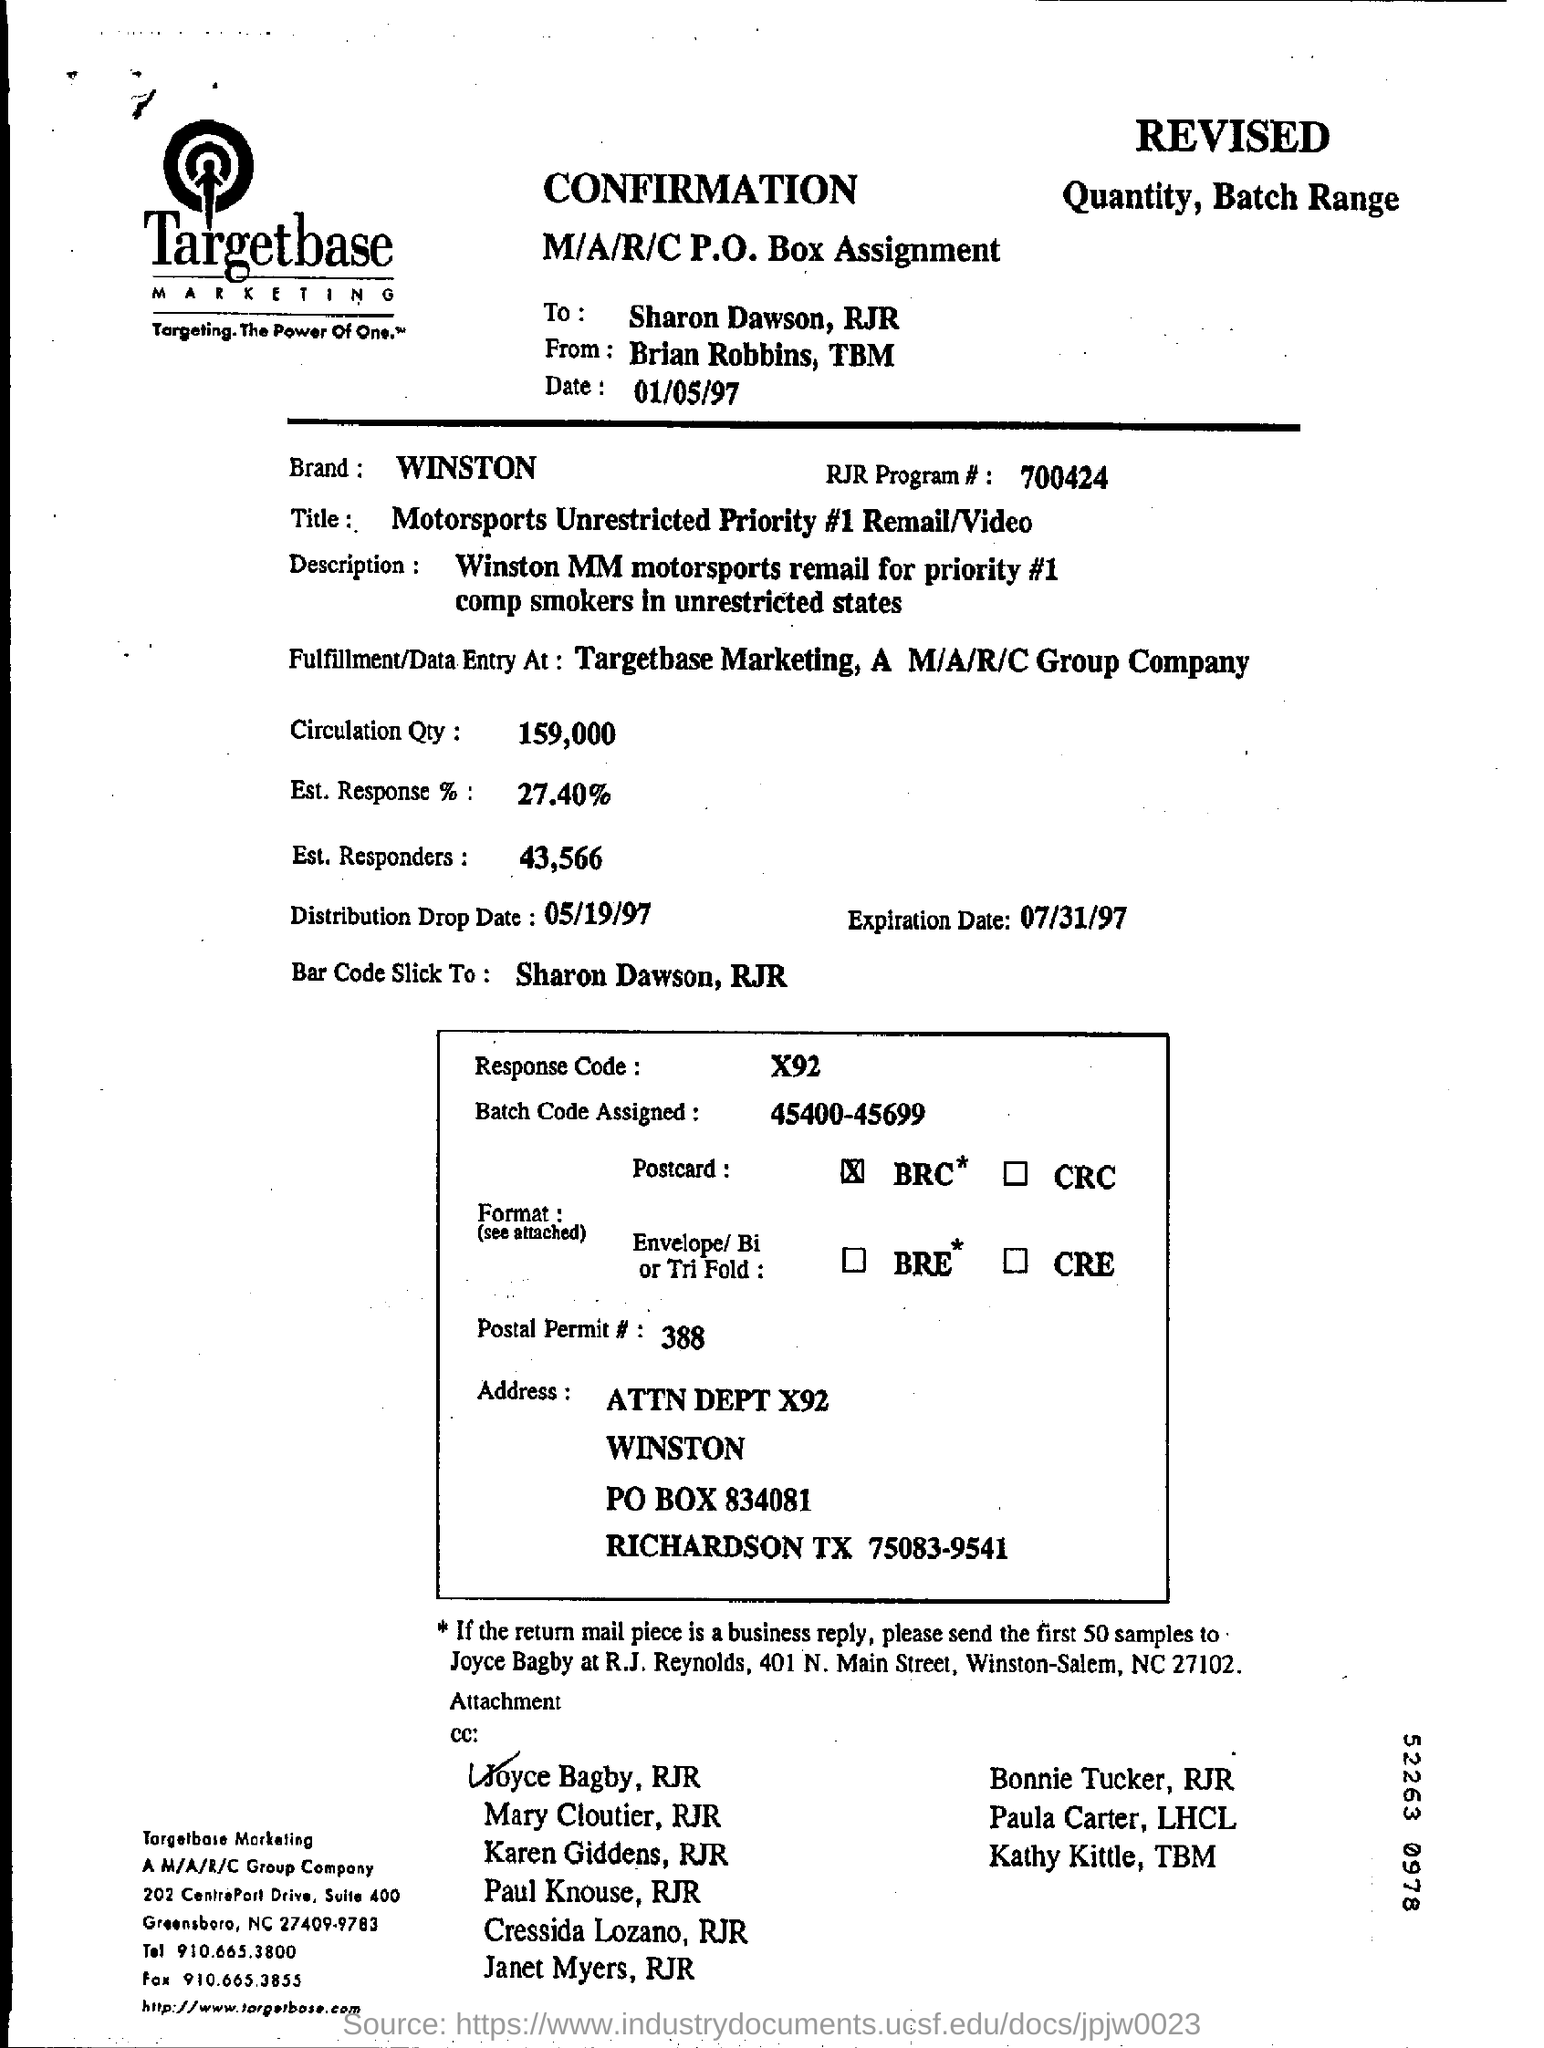Identify some key points in this picture. The name of the marketing company is Targetbase. The RJR Program is numbered as 700424. The name at the bottom of this document, Joyce Bagby, has been selected by RJR.. 